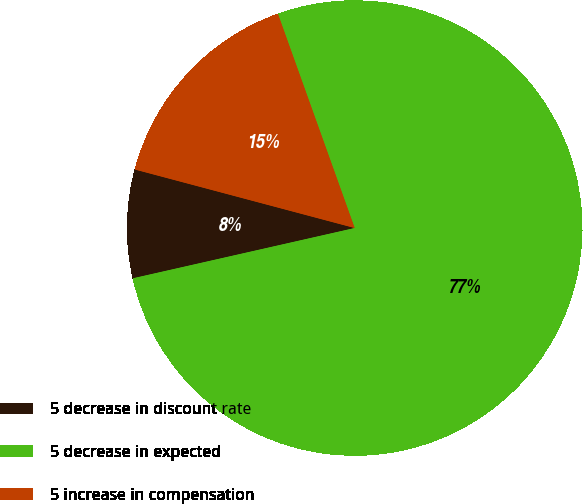<chart> <loc_0><loc_0><loc_500><loc_500><pie_chart><fcel>5 decrease in discount rate<fcel>5 decrease in expected<fcel>5 increase in compensation<nl><fcel>7.69%<fcel>76.92%<fcel>15.38%<nl></chart> 